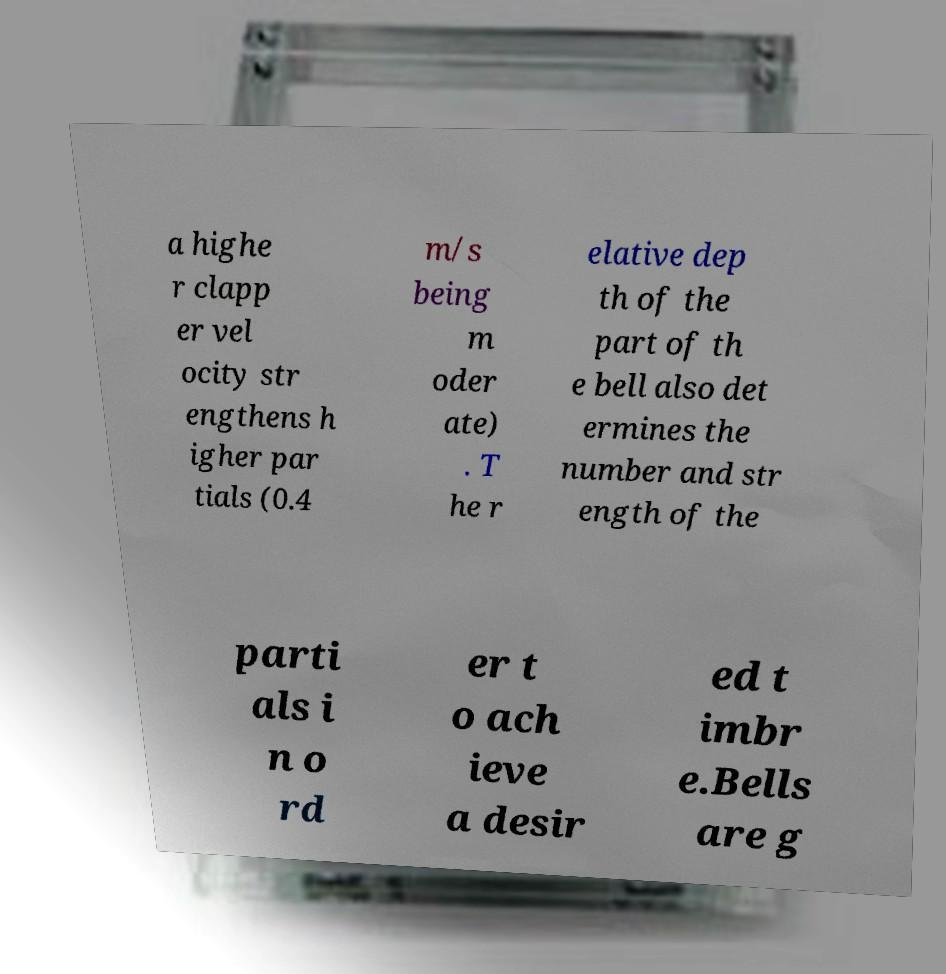For documentation purposes, I need the text within this image transcribed. Could you provide that? a highe r clapp er vel ocity str engthens h igher par tials (0.4 m/s being m oder ate) . T he r elative dep th of the part of th e bell also det ermines the number and str ength of the parti als i n o rd er t o ach ieve a desir ed t imbr e.Bells are g 